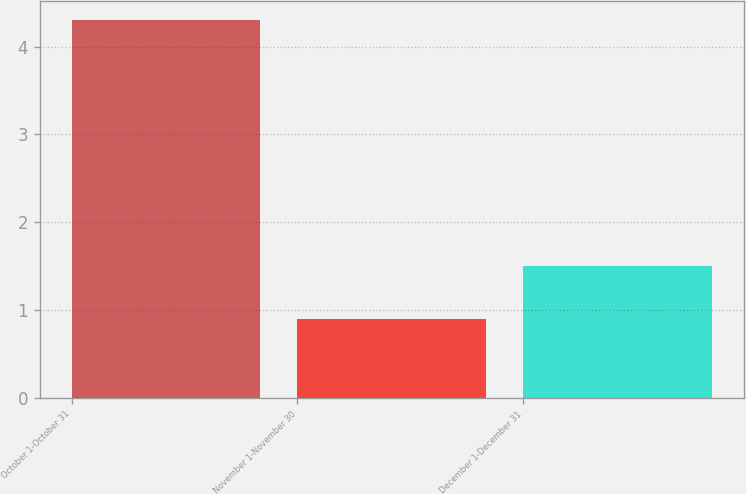Convert chart. <chart><loc_0><loc_0><loc_500><loc_500><bar_chart><fcel>October 1-October 31<fcel>November 1-November 30<fcel>December 1-December 31<nl><fcel>4.3<fcel>0.9<fcel>1.5<nl></chart> 